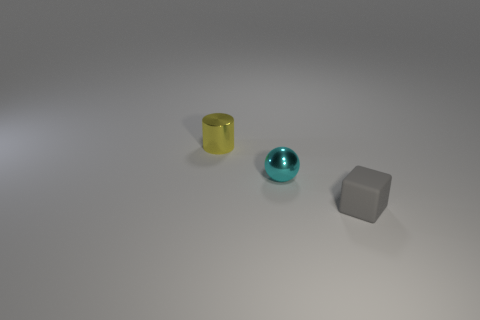There is a object that is both to the right of the yellow shiny cylinder and to the left of the gray thing; what size is it?
Provide a short and direct response. Small. Is there anything else that has the same material as the small gray object?
Make the answer very short. No. Is the material of the yellow thing the same as the thing on the right side of the tiny sphere?
Make the answer very short. No. Are there fewer tiny gray rubber blocks that are to the right of the tiny ball than cyan metallic objects behind the yellow shiny object?
Your answer should be compact. No. There is a thing in front of the cyan metallic sphere; what is its material?
Ensure brevity in your answer.  Rubber. There is a tiny object that is both in front of the metallic cylinder and behind the gray rubber thing; what is its color?
Provide a succinct answer. Cyan. There is a shiny thing behind the cyan metallic thing; what is its color?
Your answer should be compact. Yellow. Is there a gray rubber thing that has the same size as the yellow cylinder?
Keep it short and to the point. Yes. There is a yellow cylinder that is the same size as the cyan sphere; what is it made of?
Provide a short and direct response. Metal. What number of things are objects that are to the left of the small rubber object or small metal things in front of the tiny yellow thing?
Your answer should be compact. 2. 